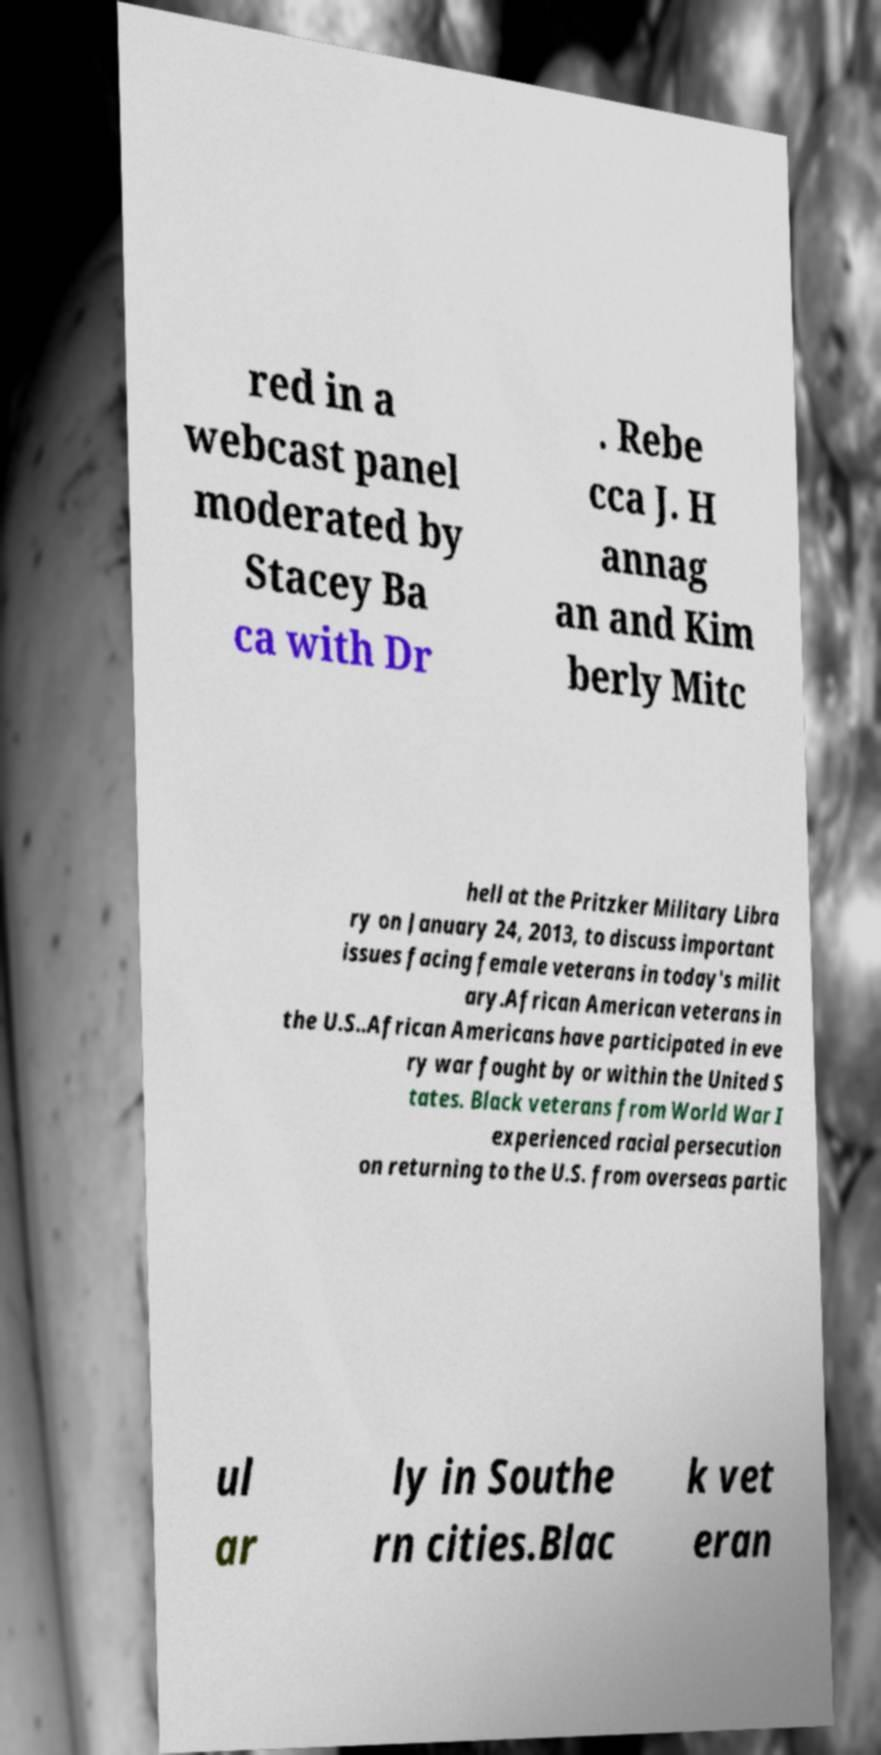There's text embedded in this image that I need extracted. Can you transcribe it verbatim? red in a webcast panel moderated by Stacey Ba ca with Dr . Rebe cca J. H annag an and Kim berly Mitc hell at the Pritzker Military Libra ry on January 24, 2013, to discuss important issues facing female veterans in today's milit ary.African American veterans in the U.S..African Americans have participated in eve ry war fought by or within the United S tates. Black veterans from World War I experienced racial persecution on returning to the U.S. from overseas partic ul ar ly in Southe rn cities.Blac k vet eran 